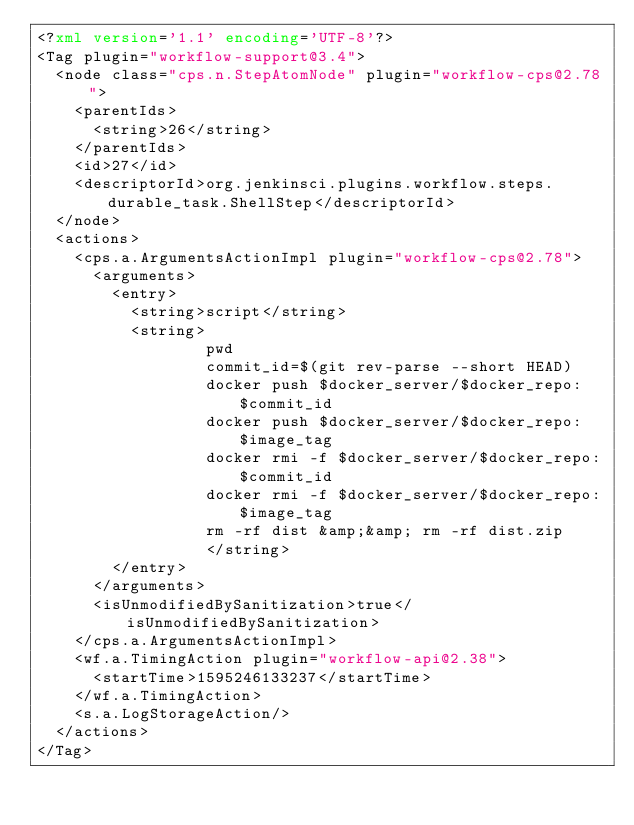<code> <loc_0><loc_0><loc_500><loc_500><_XML_><?xml version='1.1' encoding='UTF-8'?>
<Tag plugin="workflow-support@3.4">
  <node class="cps.n.StepAtomNode" plugin="workflow-cps@2.78">
    <parentIds>
      <string>26</string>
    </parentIds>
    <id>27</id>
    <descriptorId>org.jenkinsci.plugins.workflow.steps.durable_task.ShellStep</descriptorId>
  </node>
  <actions>
    <cps.a.ArgumentsActionImpl plugin="workflow-cps@2.78">
      <arguments>
        <entry>
          <string>script</string>
          <string>
                  pwd
                  commit_id=$(git rev-parse --short HEAD)
                  docker push $docker_server/$docker_repo:$commit_id
                  docker push $docker_server/$docker_repo:$image_tag
                  docker rmi -f $docker_server/$docker_repo:$commit_id
                  docker rmi -f $docker_server/$docker_repo:$image_tag
                  rm -rf dist &amp;&amp; rm -rf dist.zip
                  </string>
        </entry>
      </arguments>
      <isUnmodifiedBySanitization>true</isUnmodifiedBySanitization>
    </cps.a.ArgumentsActionImpl>
    <wf.a.TimingAction plugin="workflow-api@2.38">
      <startTime>1595246133237</startTime>
    </wf.a.TimingAction>
    <s.a.LogStorageAction/>
  </actions>
</Tag></code> 